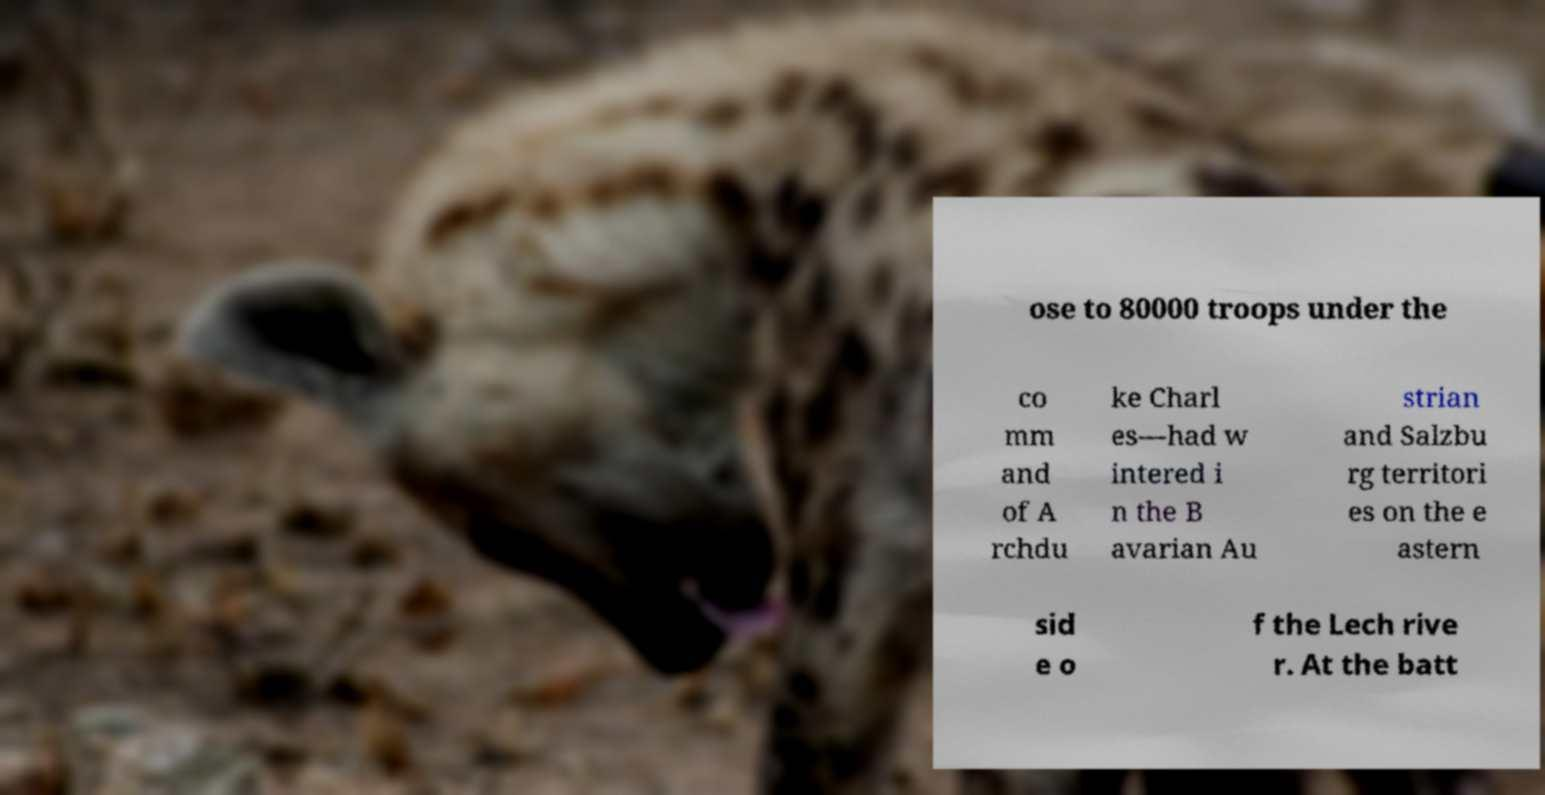Can you read and provide the text displayed in the image?This photo seems to have some interesting text. Can you extract and type it out for me? ose to 80000 troops under the co mm and of A rchdu ke Charl es—had w intered i n the B avarian Au strian and Salzbu rg territori es on the e astern sid e o f the Lech rive r. At the batt 